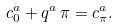<formula> <loc_0><loc_0><loc_500><loc_500>& c ^ { a } _ { 0 } + q ^ { a } \, \pi = c ^ { a } _ { \pi } .</formula> 